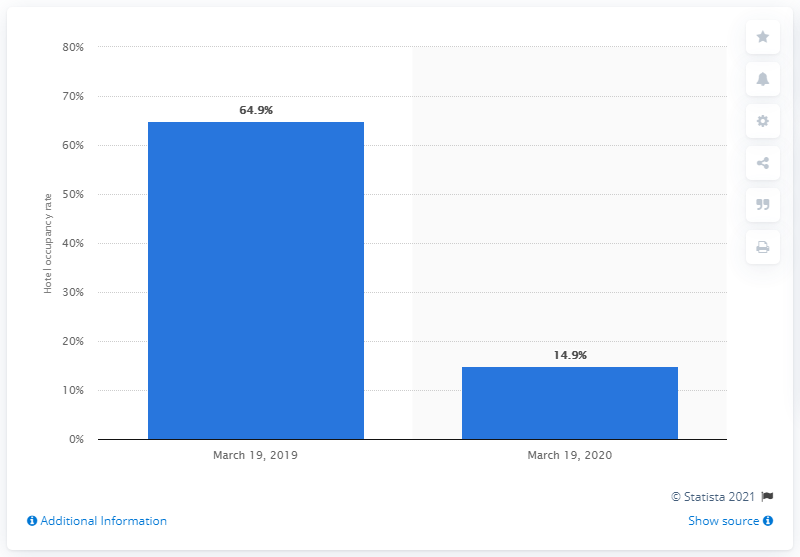Highlight a few significant elements in this photo. According to data from March 19, 2020, the hotel occupancy rate in Colombia was 14.9%. 